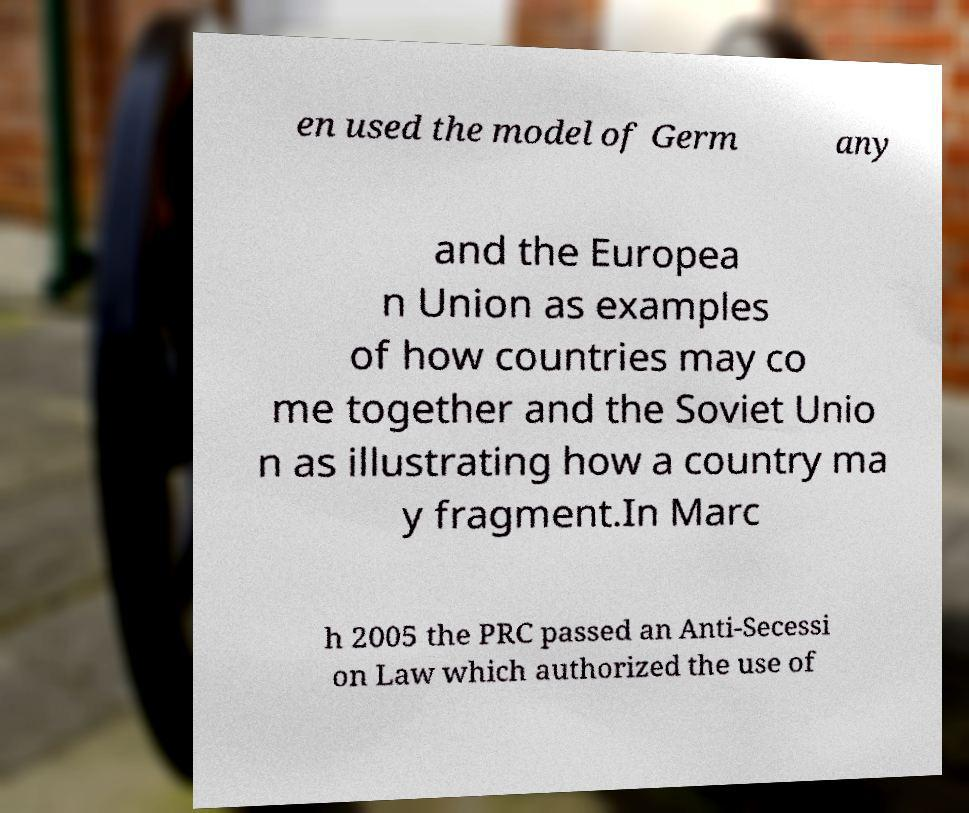There's text embedded in this image that I need extracted. Can you transcribe it verbatim? en used the model of Germ any and the Europea n Union as examples of how countries may co me together and the Soviet Unio n as illustrating how a country ma y fragment.In Marc h 2005 the PRC passed an Anti-Secessi on Law which authorized the use of 